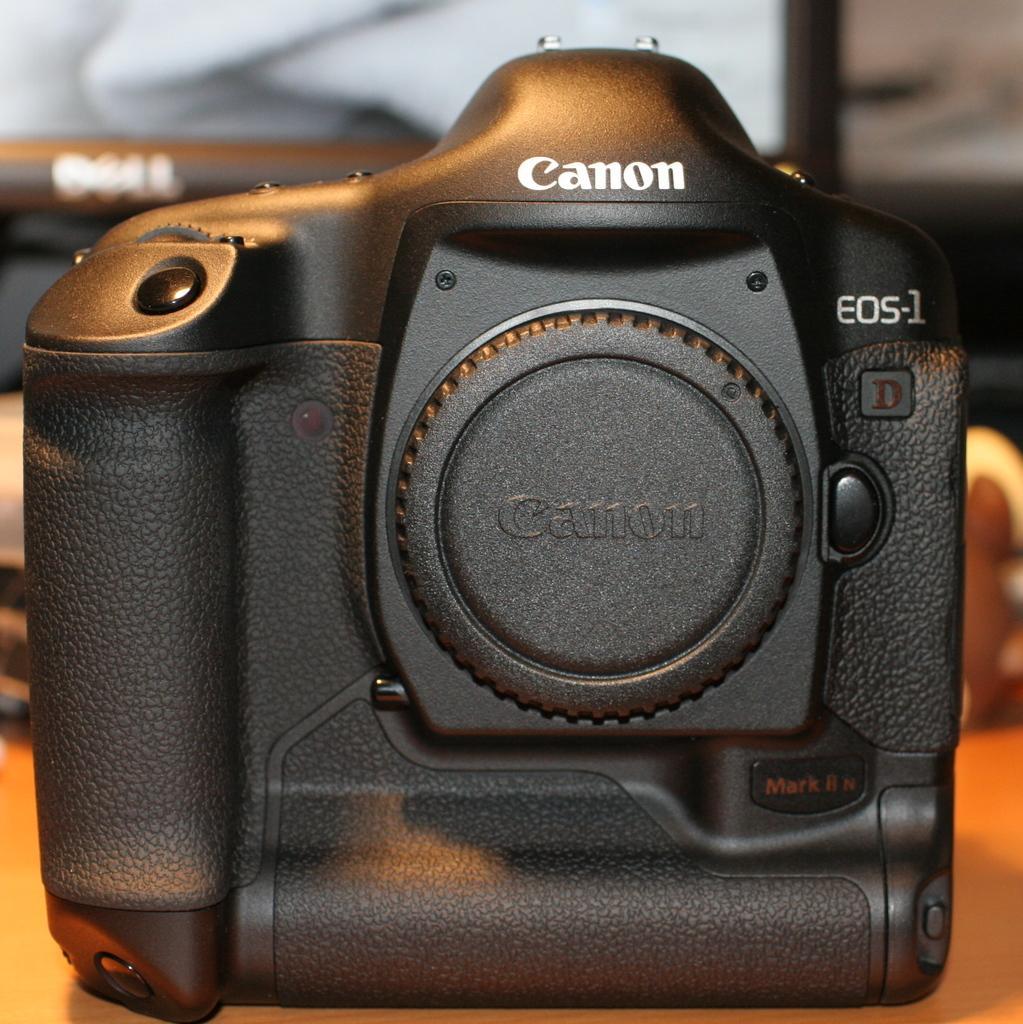Could you give a brief overview of what you see in this image? This picture shows a canon camera on the table. it is black in color and we see a desktop on the table. 